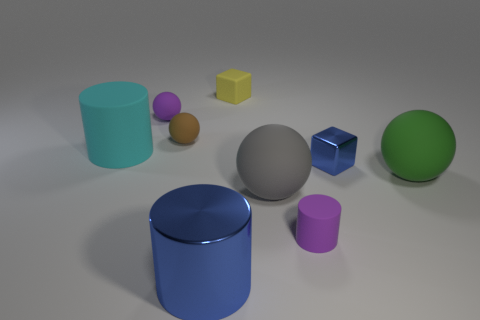There is a sphere that is the same color as the tiny cylinder; what is its size?
Provide a succinct answer. Small. What is the material of the cube that is the same color as the large metal cylinder?
Provide a succinct answer. Metal. Is the number of tiny matte objects behind the big cyan thing greater than the number of large matte cylinders that are in front of the tiny brown rubber object?
Make the answer very short. Yes. Is there a gray thing made of the same material as the tiny purple cylinder?
Keep it short and to the point. Yes. Is the color of the tiny metallic block the same as the large rubber cylinder?
Offer a very short reply. No. There is a small object that is both behind the small brown matte ball and in front of the small yellow thing; what material is it?
Your answer should be very brief. Rubber. The tiny metallic block has what color?
Your answer should be compact. Blue. How many other big metallic things are the same shape as the big blue object?
Keep it short and to the point. 0. Does the sphere right of the small blue block have the same material as the purple object that is on the left side of the big gray object?
Ensure brevity in your answer.  Yes. How big is the blue metallic object to the left of the metallic thing that is behind the metallic cylinder?
Your answer should be compact. Large. 